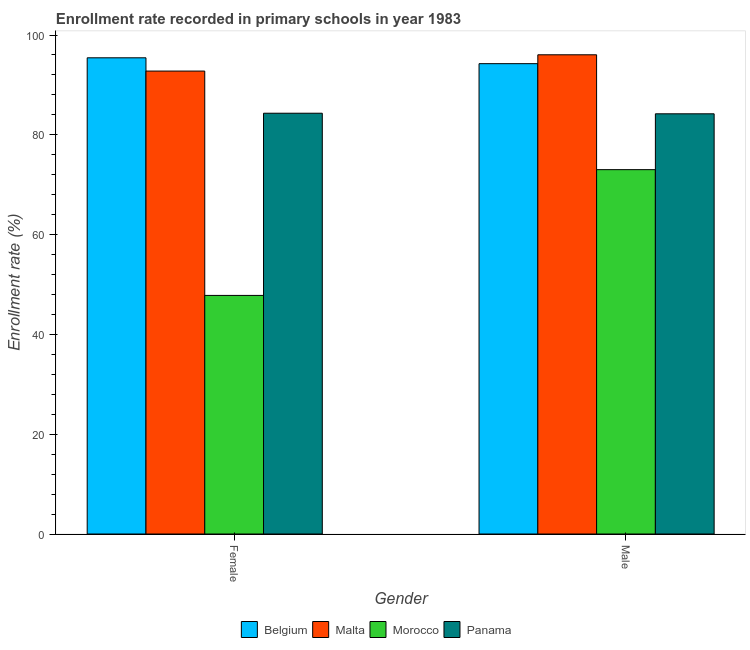How many different coloured bars are there?
Provide a short and direct response. 4. How many groups of bars are there?
Offer a terse response. 2. Are the number of bars on each tick of the X-axis equal?
Give a very brief answer. Yes. How many bars are there on the 1st tick from the right?
Your answer should be compact. 4. What is the enrollment rate of female students in Malta?
Provide a short and direct response. 92.77. Across all countries, what is the maximum enrollment rate of female students?
Your answer should be very brief. 95.43. Across all countries, what is the minimum enrollment rate of female students?
Give a very brief answer. 47.81. In which country was the enrollment rate of male students maximum?
Your answer should be compact. Malta. In which country was the enrollment rate of female students minimum?
Your answer should be compact. Morocco. What is the total enrollment rate of female students in the graph?
Ensure brevity in your answer.  320.34. What is the difference between the enrollment rate of female students in Morocco and that in Belgium?
Make the answer very short. -47.62. What is the difference between the enrollment rate of female students in Malta and the enrollment rate of male students in Panama?
Your answer should be very brief. 8.56. What is the average enrollment rate of male students per country?
Keep it short and to the point. 86.88. What is the difference between the enrollment rate of female students and enrollment rate of male students in Morocco?
Offer a terse response. -25.21. What is the ratio of the enrollment rate of male students in Malta to that in Panama?
Keep it short and to the point. 1.14. In how many countries, is the enrollment rate of female students greater than the average enrollment rate of female students taken over all countries?
Provide a short and direct response. 3. What does the 4th bar from the left in Female represents?
Make the answer very short. Panama. What does the 2nd bar from the right in Female represents?
Make the answer very short. Morocco. What is the title of the graph?
Your answer should be compact. Enrollment rate recorded in primary schools in year 1983. What is the label or title of the Y-axis?
Ensure brevity in your answer.  Enrollment rate (%). What is the Enrollment rate (%) of Belgium in Female?
Give a very brief answer. 95.43. What is the Enrollment rate (%) in Malta in Female?
Ensure brevity in your answer.  92.77. What is the Enrollment rate (%) in Morocco in Female?
Give a very brief answer. 47.81. What is the Enrollment rate (%) of Panama in Female?
Give a very brief answer. 84.33. What is the Enrollment rate (%) of Belgium in Male?
Offer a very short reply. 94.26. What is the Enrollment rate (%) in Malta in Male?
Your response must be concise. 96.04. What is the Enrollment rate (%) of Morocco in Male?
Keep it short and to the point. 73.02. What is the Enrollment rate (%) of Panama in Male?
Keep it short and to the point. 84.21. Across all Gender, what is the maximum Enrollment rate (%) of Belgium?
Your answer should be very brief. 95.43. Across all Gender, what is the maximum Enrollment rate (%) of Malta?
Your answer should be compact. 96.04. Across all Gender, what is the maximum Enrollment rate (%) of Morocco?
Offer a very short reply. 73.02. Across all Gender, what is the maximum Enrollment rate (%) in Panama?
Your answer should be compact. 84.33. Across all Gender, what is the minimum Enrollment rate (%) of Belgium?
Ensure brevity in your answer.  94.26. Across all Gender, what is the minimum Enrollment rate (%) of Malta?
Give a very brief answer. 92.77. Across all Gender, what is the minimum Enrollment rate (%) of Morocco?
Make the answer very short. 47.81. Across all Gender, what is the minimum Enrollment rate (%) of Panama?
Offer a terse response. 84.21. What is the total Enrollment rate (%) of Belgium in the graph?
Give a very brief answer. 189.69. What is the total Enrollment rate (%) in Malta in the graph?
Keep it short and to the point. 188.81. What is the total Enrollment rate (%) of Morocco in the graph?
Give a very brief answer. 120.83. What is the total Enrollment rate (%) of Panama in the graph?
Ensure brevity in your answer.  168.53. What is the difference between the Enrollment rate (%) in Belgium in Female and that in Male?
Ensure brevity in your answer.  1.18. What is the difference between the Enrollment rate (%) in Malta in Female and that in Male?
Your answer should be very brief. -3.26. What is the difference between the Enrollment rate (%) in Morocco in Female and that in Male?
Offer a terse response. -25.21. What is the difference between the Enrollment rate (%) in Panama in Female and that in Male?
Offer a very short reply. 0.12. What is the difference between the Enrollment rate (%) in Belgium in Female and the Enrollment rate (%) in Malta in Male?
Your answer should be compact. -0.6. What is the difference between the Enrollment rate (%) in Belgium in Female and the Enrollment rate (%) in Morocco in Male?
Keep it short and to the point. 22.41. What is the difference between the Enrollment rate (%) in Belgium in Female and the Enrollment rate (%) in Panama in Male?
Your answer should be very brief. 11.22. What is the difference between the Enrollment rate (%) in Malta in Female and the Enrollment rate (%) in Morocco in Male?
Offer a terse response. 19.75. What is the difference between the Enrollment rate (%) of Malta in Female and the Enrollment rate (%) of Panama in Male?
Provide a short and direct response. 8.56. What is the difference between the Enrollment rate (%) in Morocco in Female and the Enrollment rate (%) in Panama in Male?
Provide a short and direct response. -36.4. What is the average Enrollment rate (%) in Belgium per Gender?
Your response must be concise. 94.84. What is the average Enrollment rate (%) of Malta per Gender?
Ensure brevity in your answer.  94.4. What is the average Enrollment rate (%) of Morocco per Gender?
Your response must be concise. 60.42. What is the average Enrollment rate (%) in Panama per Gender?
Make the answer very short. 84.27. What is the difference between the Enrollment rate (%) of Belgium and Enrollment rate (%) of Malta in Female?
Your response must be concise. 2.66. What is the difference between the Enrollment rate (%) of Belgium and Enrollment rate (%) of Morocco in Female?
Give a very brief answer. 47.62. What is the difference between the Enrollment rate (%) of Belgium and Enrollment rate (%) of Panama in Female?
Make the answer very short. 11.11. What is the difference between the Enrollment rate (%) in Malta and Enrollment rate (%) in Morocco in Female?
Give a very brief answer. 44.96. What is the difference between the Enrollment rate (%) of Malta and Enrollment rate (%) of Panama in Female?
Offer a very short reply. 8.45. What is the difference between the Enrollment rate (%) of Morocco and Enrollment rate (%) of Panama in Female?
Offer a terse response. -36.51. What is the difference between the Enrollment rate (%) in Belgium and Enrollment rate (%) in Malta in Male?
Provide a succinct answer. -1.78. What is the difference between the Enrollment rate (%) in Belgium and Enrollment rate (%) in Morocco in Male?
Give a very brief answer. 21.24. What is the difference between the Enrollment rate (%) of Belgium and Enrollment rate (%) of Panama in Male?
Give a very brief answer. 10.05. What is the difference between the Enrollment rate (%) in Malta and Enrollment rate (%) in Morocco in Male?
Offer a terse response. 23.02. What is the difference between the Enrollment rate (%) in Malta and Enrollment rate (%) in Panama in Male?
Your answer should be compact. 11.83. What is the difference between the Enrollment rate (%) in Morocco and Enrollment rate (%) in Panama in Male?
Make the answer very short. -11.19. What is the ratio of the Enrollment rate (%) of Belgium in Female to that in Male?
Your response must be concise. 1.01. What is the ratio of the Enrollment rate (%) of Malta in Female to that in Male?
Provide a short and direct response. 0.97. What is the ratio of the Enrollment rate (%) in Morocco in Female to that in Male?
Your response must be concise. 0.65. What is the ratio of the Enrollment rate (%) in Panama in Female to that in Male?
Provide a succinct answer. 1. What is the difference between the highest and the second highest Enrollment rate (%) of Belgium?
Keep it short and to the point. 1.18. What is the difference between the highest and the second highest Enrollment rate (%) in Malta?
Your answer should be very brief. 3.26. What is the difference between the highest and the second highest Enrollment rate (%) in Morocco?
Your answer should be compact. 25.21. What is the difference between the highest and the second highest Enrollment rate (%) of Panama?
Offer a very short reply. 0.12. What is the difference between the highest and the lowest Enrollment rate (%) in Belgium?
Provide a short and direct response. 1.18. What is the difference between the highest and the lowest Enrollment rate (%) of Malta?
Ensure brevity in your answer.  3.26. What is the difference between the highest and the lowest Enrollment rate (%) of Morocco?
Provide a succinct answer. 25.21. What is the difference between the highest and the lowest Enrollment rate (%) in Panama?
Your answer should be compact. 0.12. 